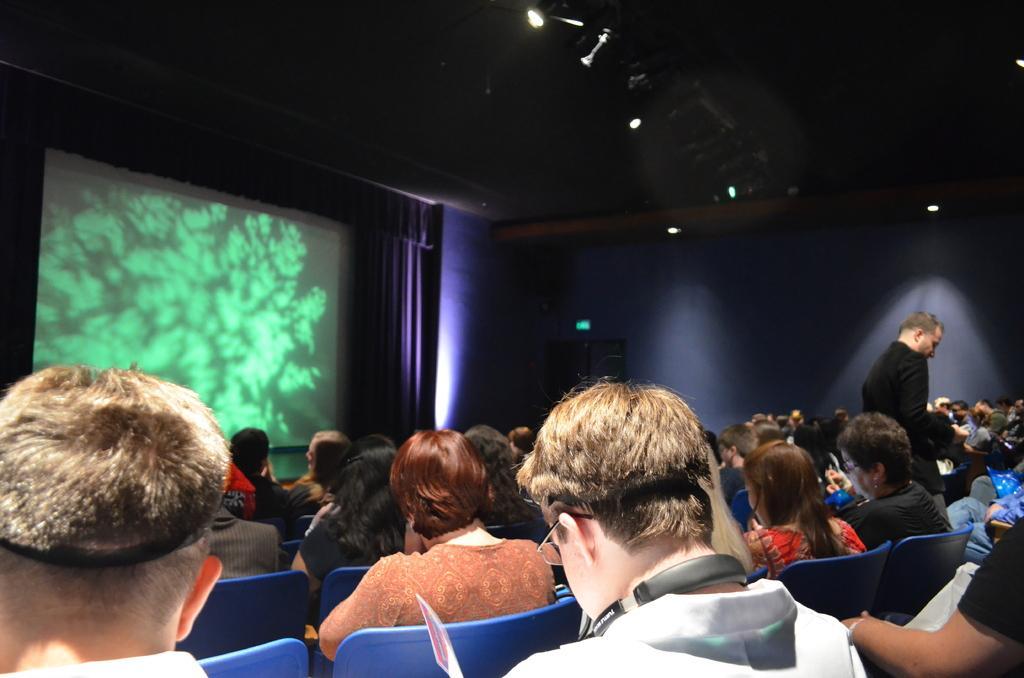In one or two sentences, can you explain what this image depicts? In this image I can see number of persons are sitting on chairs which are blue in color. I can see a person wearing black color dress is stunning. In the background I can see the wall, the ceiling, few lights to the ceiling, the curtain and the sky. 